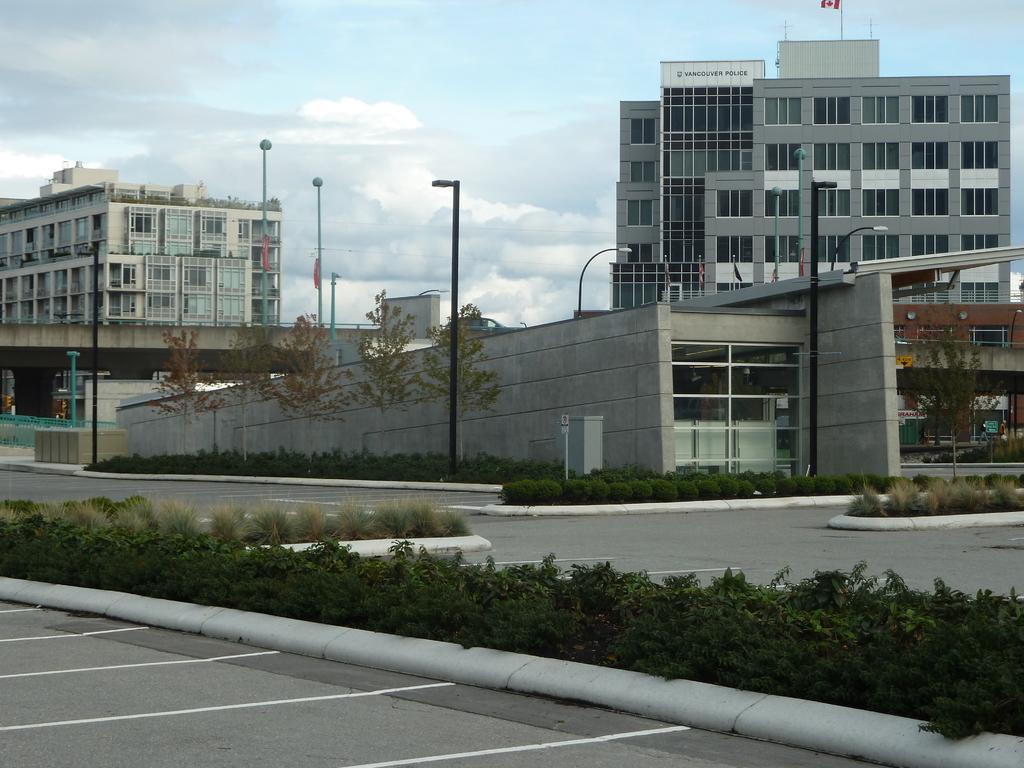Please provide a concise description of this image. In the picture I can see street lights, plants, roads which has white color lines on them, trees and some other objects on the ground. In the background I can see the sky and buildings. 